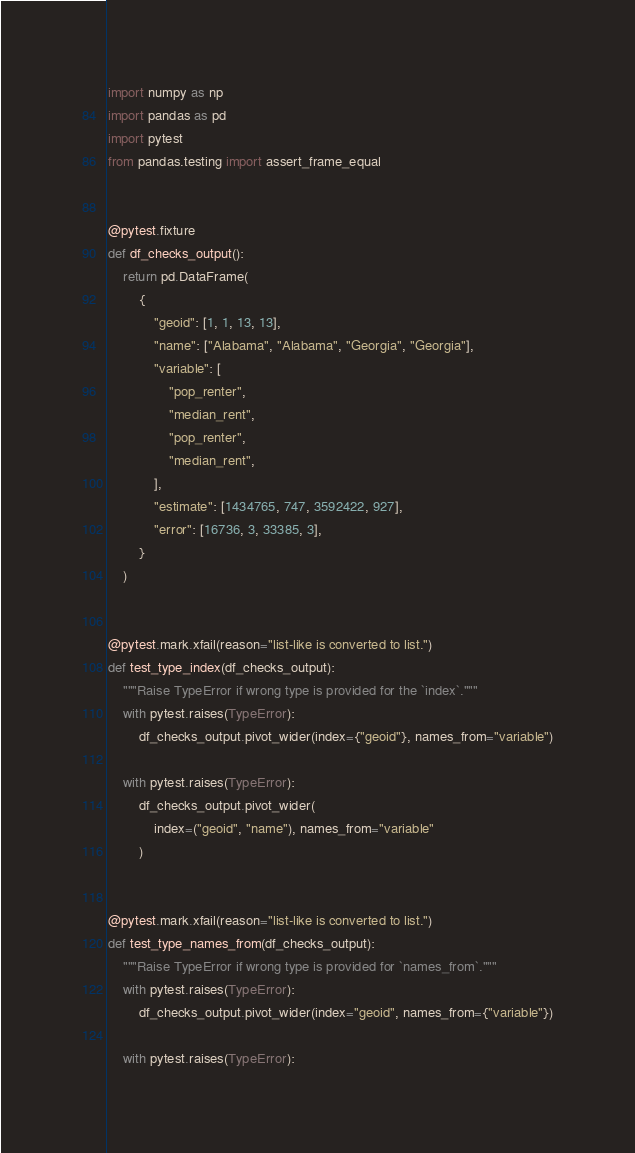Convert code to text. <code><loc_0><loc_0><loc_500><loc_500><_Python_>import numpy as np
import pandas as pd
import pytest
from pandas.testing import assert_frame_equal


@pytest.fixture
def df_checks_output():
    return pd.DataFrame(
        {
            "geoid": [1, 1, 13, 13],
            "name": ["Alabama", "Alabama", "Georgia", "Georgia"],
            "variable": [
                "pop_renter",
                "median_rent",
                "pop_renter",
                "median_rent",
            ],
            "estimate": [1434765, 747, 3592422, 927],
            "error": [16736, 3, 33385, 3],
        }
    )


@pytest.mark.xfail(reason="list-like is converted to list.")
def test_type_index(df_checks_output):
    """Raise TypeError if wrong type is provided for the `index`."""
    with pytest.raises(TypeError):
        df_checks_output.pivot_wider(index={"geoid"}, names_from="variable")

    with pytest.raises(TypeError):
        df_checks_output.pivot_wider(
            index=("geoid", "name"), names_from="variable"
        )


@pytest.mark.xfail(reason="list-like is converted to list.")
def test_type_names_from(df_checks_output):
    """Raise TypeError if wrong type is provided for `names_from`."""
    with pytest.raises(TypeError):
        df_checks_output.pivot_wider(index="geoid", names_from={"variable"})

    with pytest.raises(TypeError):</code> 